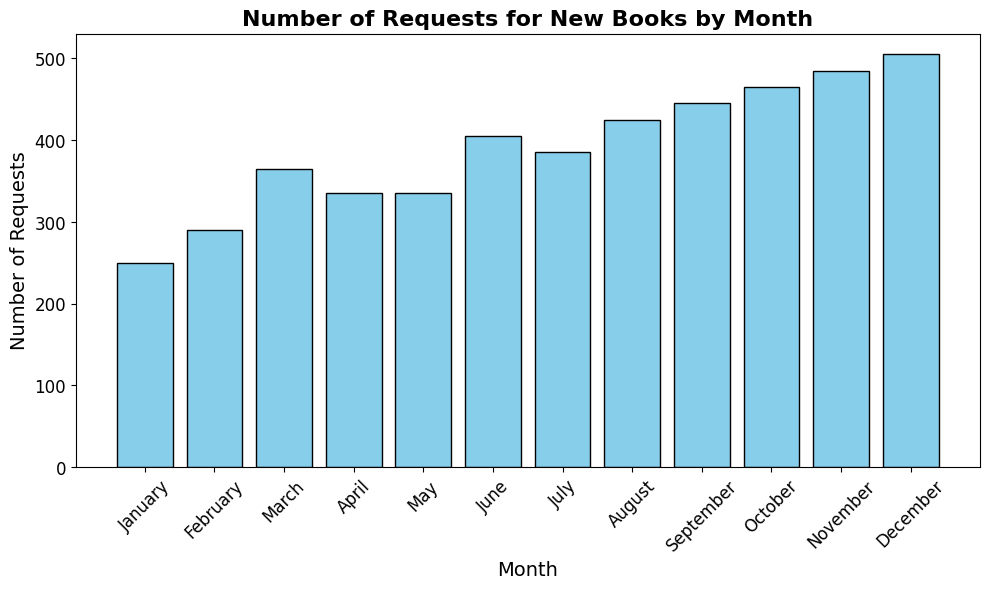What's the total number of book requests in March across both years? Sum the number of requests in March for both years: 180 (first year) + 185 (second year).
Answer: 365 Which month had the highest number of requests? Identify the month with the highest bar visually. November and December have the tallest bars, both showing 495 requests each.
Answer: November and December In which month does the number of requests increase consistently from January to December? Observe the trend from January to December. If the heights of the bars are consistently increasing, it indicates the requests increase. Here, from January's 250 to December's 490.
Answer: January to December How many more requests were there in October compared to April in the first year? Subtract the number of requests in April from October: 230 (October) - 160 (April).
Answer: 70 What is the average number of requests per month in the second year? Calculate the sum of the requests for the second year and divide by the number of months: (130+140+185+175+165+205+195+215+225+235+245+255) / 12.
Answer: 207.5 Which month shows the largest increase in the number of requests from the first to the second year? Compare the number of requests for each month between the two years and identify the largest increase.
Answer: January (10 requests increase) Which month had the least number of requests in the second year? Look for the month with the shortest bar in the second year data. February has the shortest bar with 140 requests.
Answer: February How does the number of requests in June compare between the two years? Compare the heights of the bars for June between the two years: 200 (first year) and 205 (second year).
Answer: The second year has 5 more requests What is the difference in the total number of requests between December and July in the second year? Subtract the number of requests in July from December in the second year: 255 (December) - 195 (July).
Answer: 60 What's the median number of monthly requests for the first year? Arrange the number of requests for each month in the first year in ascending order and find the median: (120, 130, 140, 150, 160, 170, 180, 190, 200, 210, 220, 230). The median is the average of the 6th and 7th values: (170 + 180) / 2.
Answer: 175 